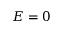Convert formula to latex. <formula><loc_0><loc_0><loc_500><loc_500>E = 0</formula> 